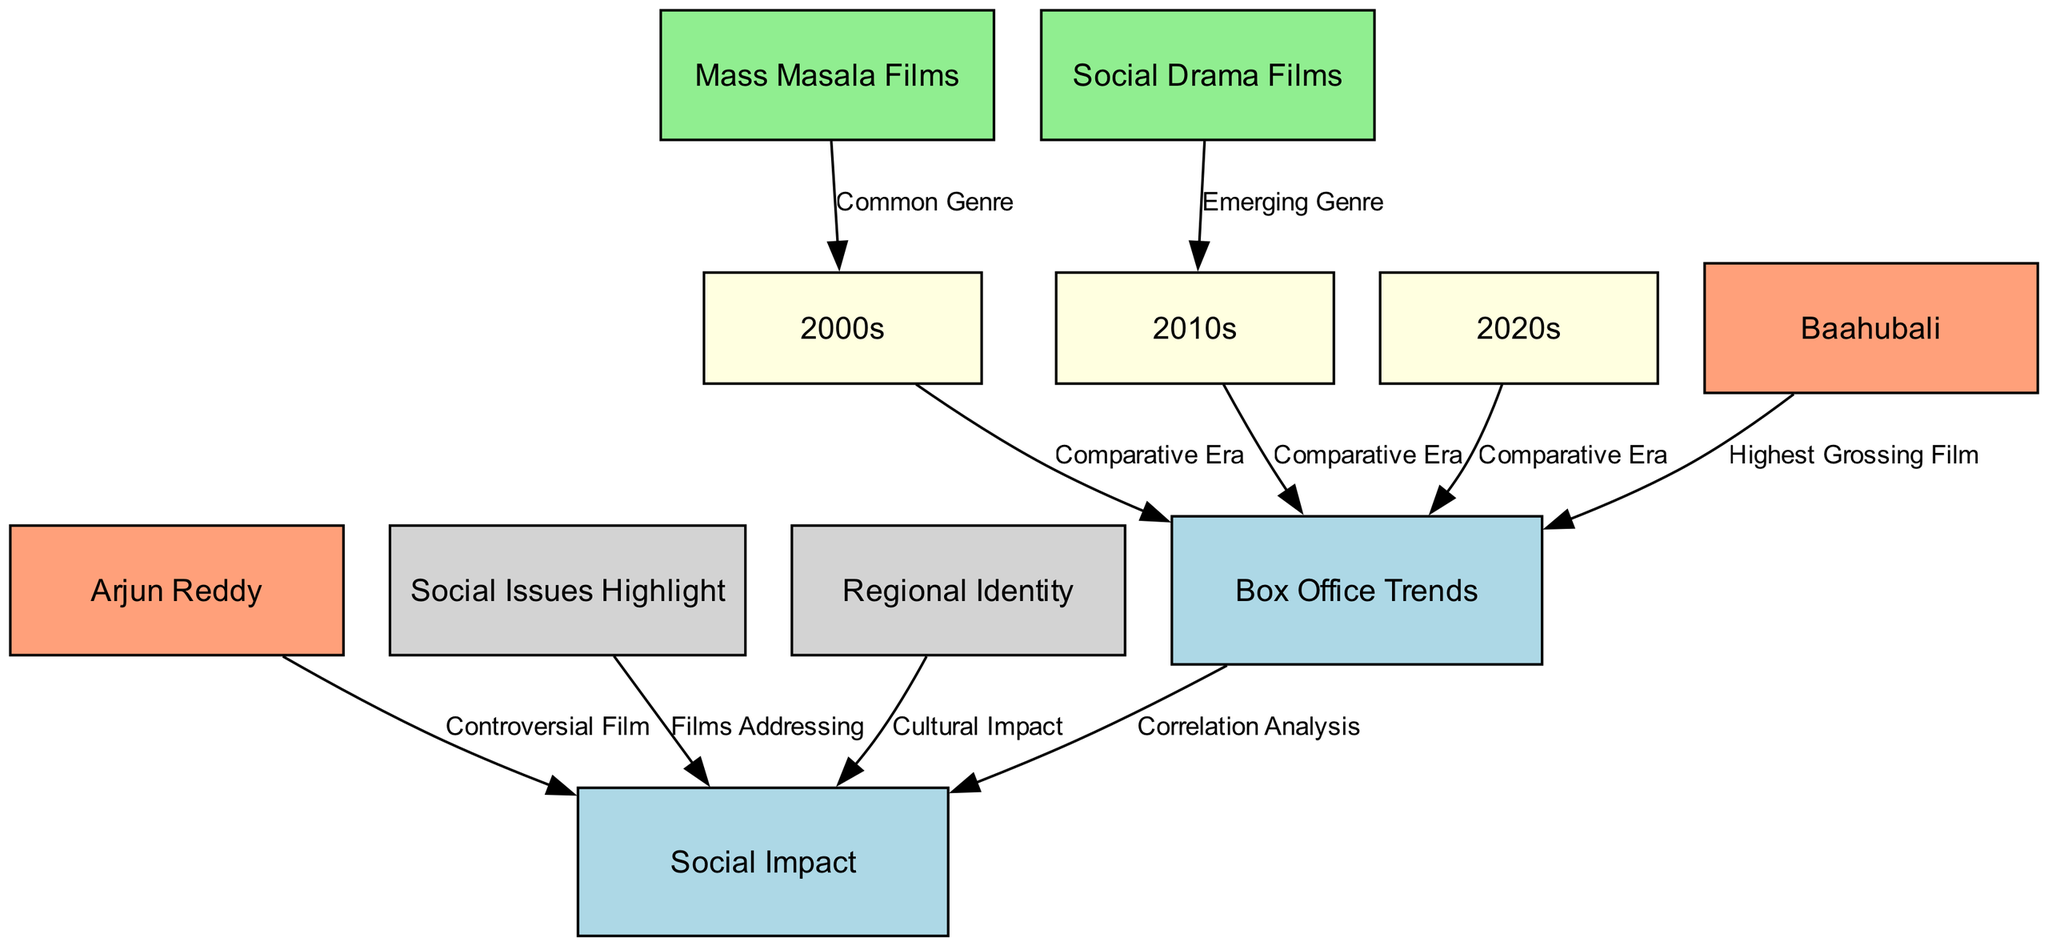What are the three decades highlighted in the diagram? The nodes labeled "2000s," "2010s," and "2020s" represent the three decades highlighted in the diagram, showing the trends in box office and social impact across these years.
Answer: 2000s, 2010s, 2020s Which film is noted as the highest-grossing film? The edge from the node "bahubali" to "box_office_trends" indicates that "Baahubali" is recognized as the highest-grossing film in the diagram.
Answer: Baahubali What type of film genre is associated with the 2000s? The edge from "mass_masala" to the node "2000s" shows that "Mass Masala Films" is the genre associated with this decade.
Answer: Mass Masala Films Which film is labeled as controversial? The edge from the node "arjun_reddy" to "social_impact" indicates that "Arjun Reddy" is identified as a controversial film.
Answer: Arjun Reddy How do box office trends correlate with social impact? The edge from "box_office_trends" to "social_impact" labeled as "Correlation Analysis" signifies that there is a relationship or correlation between box office trends and social impact, as represented in the diagram.
Answer: Correlation Analysis What do the nodes "social_issues" and "regional_identity" contribute to? The edges from "social_issues" and "regional_identity" to "social_impact" indicate that both contribute to discussions related to social impact in cinema, specifically addressing significant themes in the films.
Answer: Social Impact What emerging genre is highlighted for the 2010s? The edge from "social_drama" to "2010s" suggests that "Social Drama Films" is the emerging genre of the 2010s as depicted in the diagram.
Answer: Social Drama Films How many nodes are related to social impact? The nodes "social_impact," "social_issues," and "regional_identity" directly relate to social impact, meaning there are three nodes associated with this aspect in the diagram.
Answer: Three 